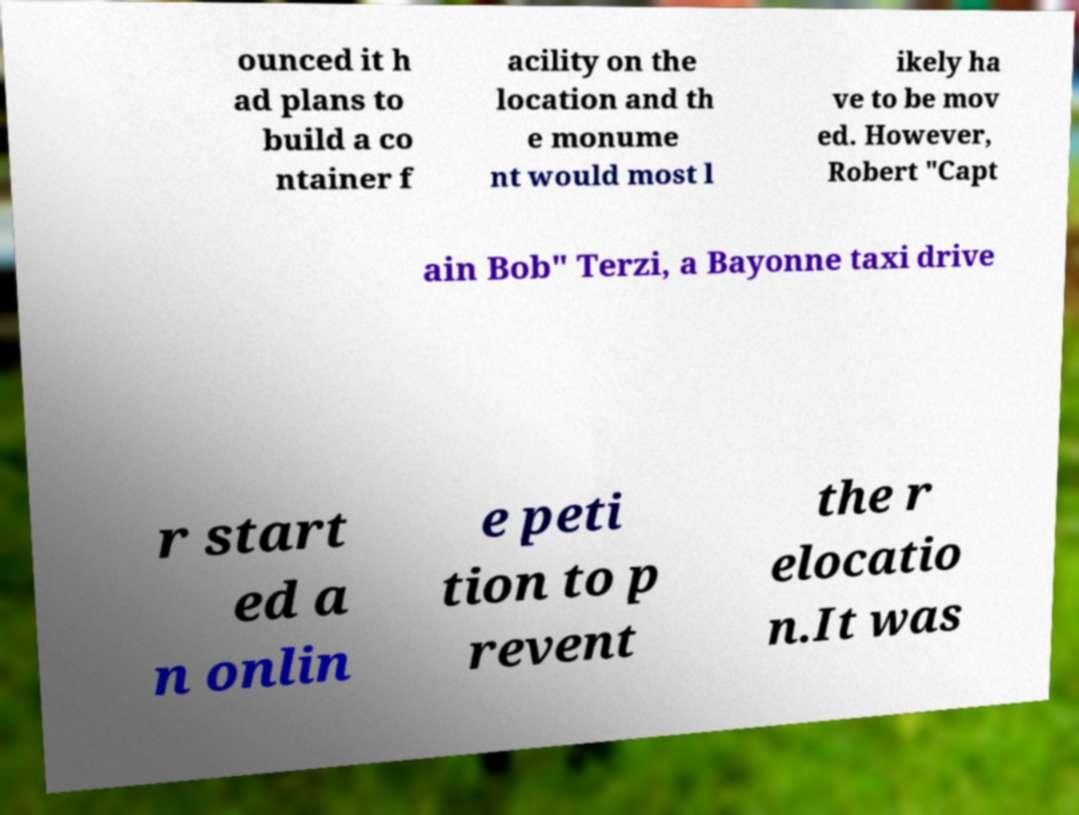Can you read and provide the text displayed in the image?This photo seems to have some interesting text. Can you extract and type it out for me? ounced it h ad plans to build a co ntainer f acility on the location and th e monume nt would most l ikely ha ve to be mov ed. However, Robert "Capt ain Bob" Terzi, a Bayonne taxi drive r start ed a n onlin e peti tion to p revent the r elocatio n.It was 